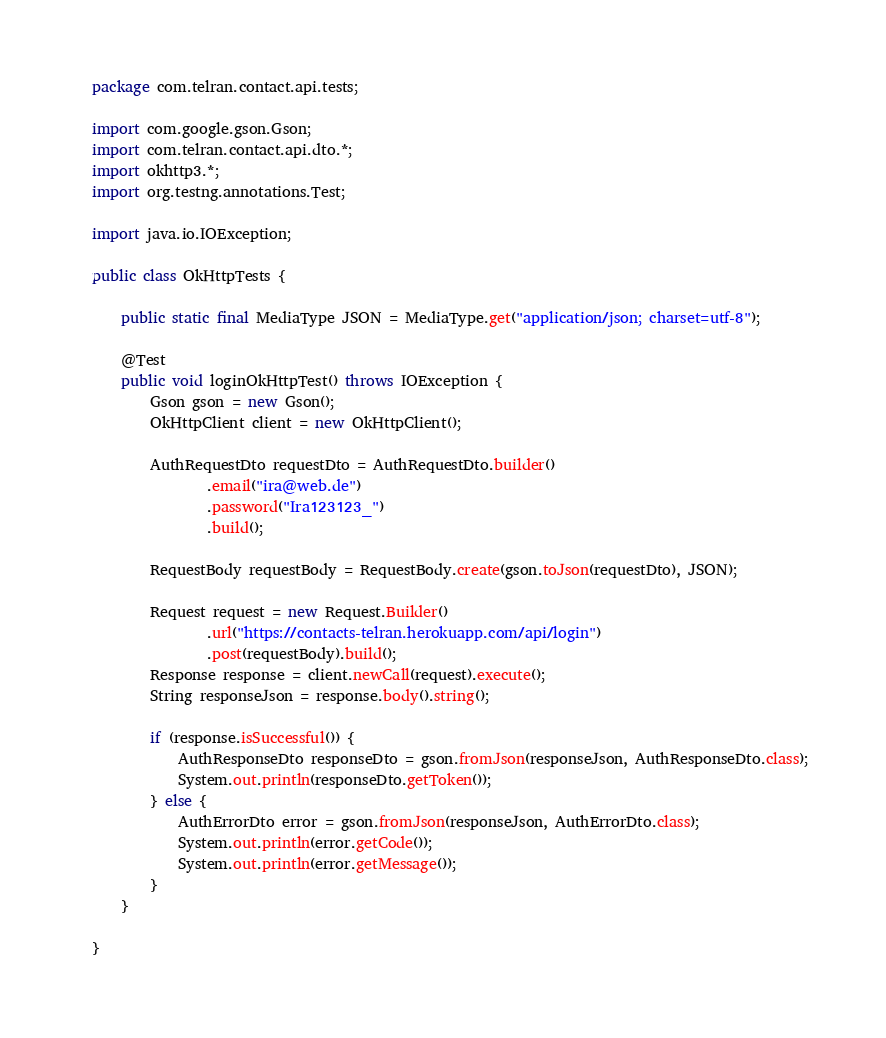Convert code to text. <code><loc_0><loc_0><loc_500><loc_500><_Java_>package com.telran.contact.api.tests;

import com.google.gson.Gson;
import com.telran.contact.api.dto.*;
import okhttp3.*;
import org.testng.annotations.Test;

import java.io.IOException;

public class OkHttpTests {

    public static final MediaType JSON = MediaType.get("application/json; charset=utf-8");

    @Test
    public void loginOkHttpTest() throws IOException {
        Gson gson = new Gson();
        OkHttpClient client = new OkHttpClient();

        AuthRequestDto requestDto = AuthRequestDto.builder()
                .email("ira@web.de")
                .password("Ira123123_")
                .build();

        RequestBody requestBody = RequestBody.create(gson.toJson(requestDto), JSON);

        Request request = new Request.Builder()
                .url("https://contacts-telran.herokuapp.com/api/login")
                .post(requestBody).build();
        Response response = client.newCall(request).execute();
        String responseJson = response.body().string();

        if (response.isSuccessful()) {
            AuthResponseDto responseDto = gson.fromJson(responseJson, AuthResponseDto.class);
            System.out.println(responseDto.getToken());
        } else {
            AuthErrorDto error = gson.fromJson(responseJson, AuthErrorDto.class);
            System.out.println(error.getCode());
            System.out.println(error.getMessage());
        }
    }

}
</code> 